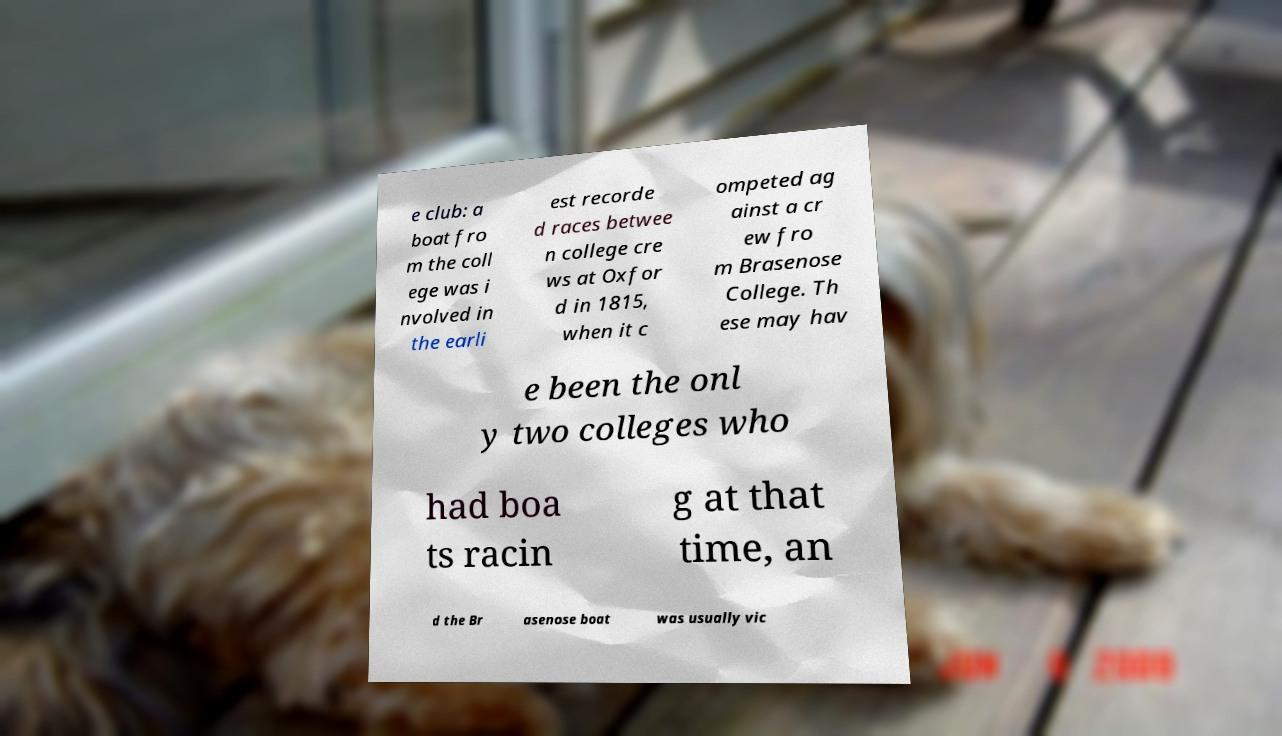There's text embedded in this image that I need extracted. Can you transcribe it verbatim? e club: a boat fro m the coll ege was i nvolved in the earli est recorde d races betwee n college cre ws at Oxfor d in 1815, when it c ompeted ag ainst a cr ew fro m Brasenose College. Th ese may hav e been the onl y two colleges who had boa ts racin g at that time, an d the Br asenose boat was usually vic 